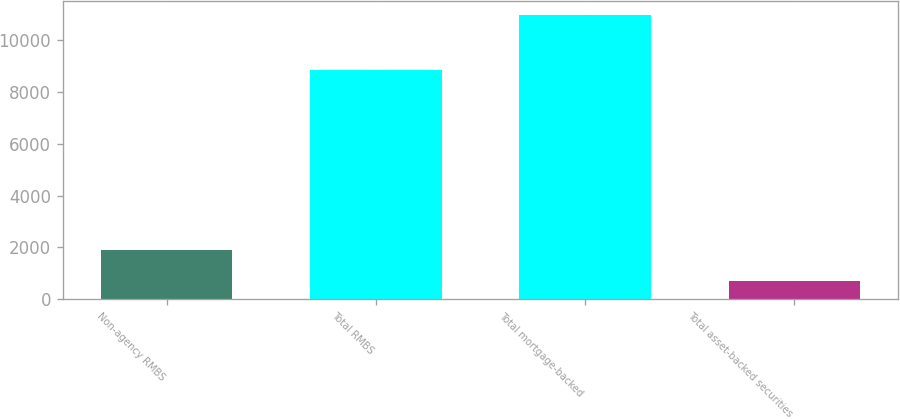Convert chart to OTSL. <chart><loc_0><loc_0><loc_500><loc_500><bar_chart><fcel>Non-agency RMBS<fcel>Total RMBS<fcel>Total mortgage-backed<fcel>Total asset-backed securities<nl><fcel>1885<fcel>8845<fcel>10986<fcel>709<nl></chart> 